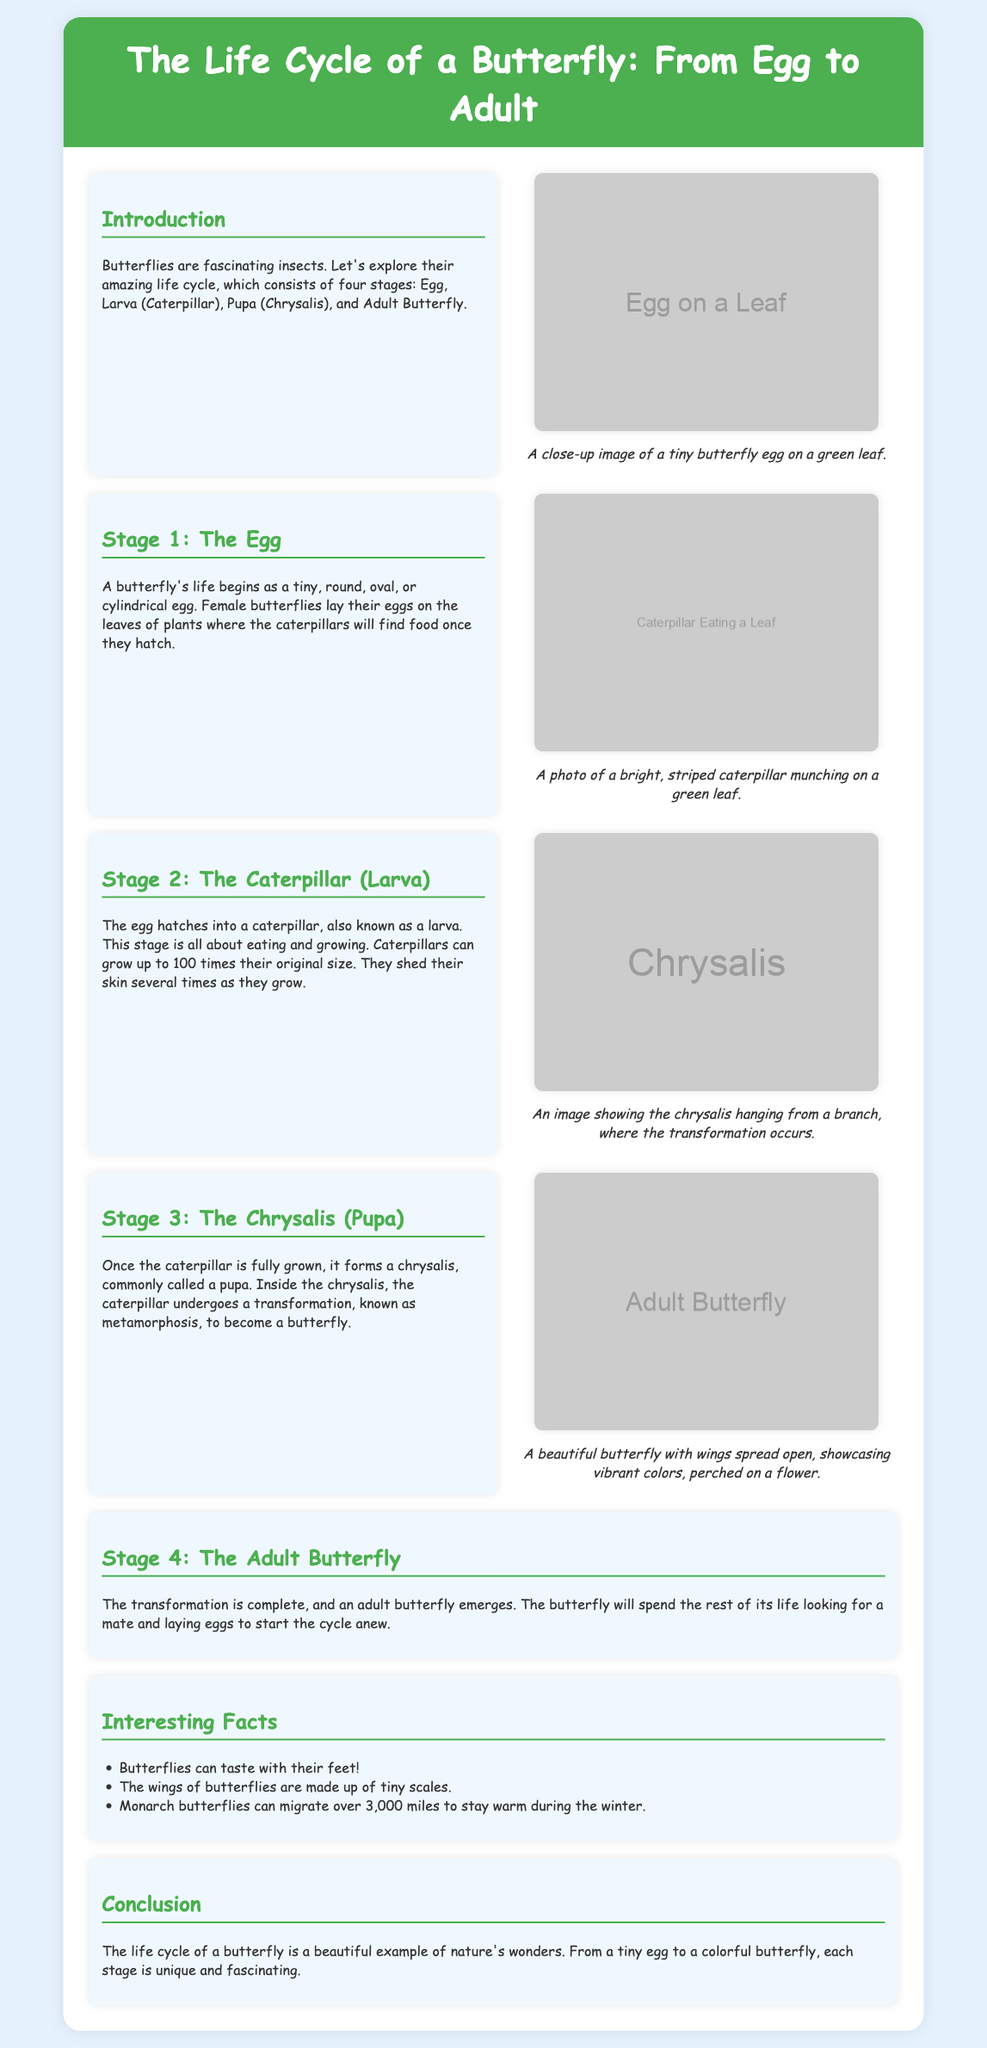What are the four stages of a butterfly's life cycle? The four stages of a butterfly's life cycle are Egg, Larva (Caterpillar), Pupa (Chrysalis), and Adult Butterfly.
Answer: Egg, Larva (Caterpillar), Pupa (Chrysalis), Adult Butterfly What does a caterpillar primarily do during its life? The caterpillar primarily eats and grows during its life stage.
Answer: Eating and growing How much can caterpillars grow compared to their original size? Caterpillars can grow up to 100 times their original size.
Answer: 100 times What happens inside the chrysalis? Inside the chrysalis, the caterpillar undergoes a transformation known as metamorphosis.
Answer: Metamorphosis What can butterflies taste with? Butterflies can taste with their feet.
Answer: Feet What is a unique feature of butterfly wings? The wings of butterflies are made up of tiny scales.
Answer: Tiny scales How far can monarch butterflies migrate? Monarch butterflies can migrate over 3,000 miles.
Answer: 3,000 miles What does the adult butterfly do after emerging? The adult butterfly looks for a mate and lays eggs to start the cycle anew.
Answer: Looks for a mate and lays eggs What is the background color of the document? The background color of the document is light blue.
Answer: Light blue 